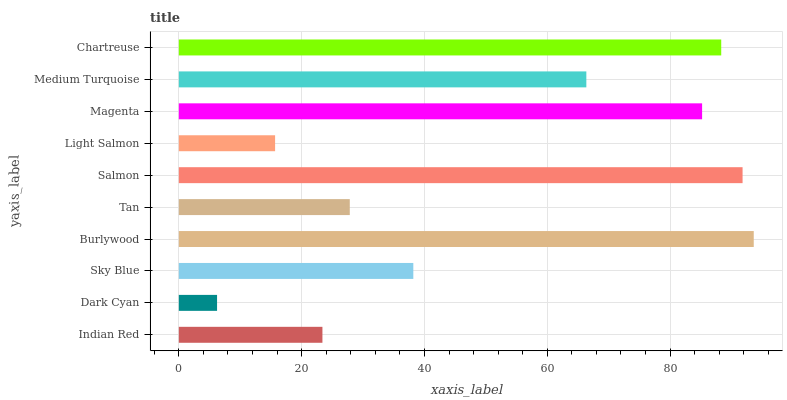Is Dark Cyan the minimum?
Answer yes or no. Yes. Is Burlywood the maximum?
Answer yes or no. Yes. Is Sky Blue the minimum?
Answer yes or no. No. Is Sky Blue the maximum?
Answer yes or no. No. Is Sky Blue greater than Dark Cyan?
Answer yes or no. Yes. Is Dark Cyan less than Sky Blue?
Answer yes or no. Yes. Is Dark Cyan greater than Sky Blue?
Answer yes or no. No. Is Sky Blue less than Dark Cyan?
Answer yes or no. No. Is Medium Turquoise the high median?
Answer yes or no. Yes. Is Sky Blue the low median?
Answer yes or no. Yes. Is Chartreuse the high median?
Answer yes or no. No. Is Burlywood the low median?
Answer yes or no. No. 